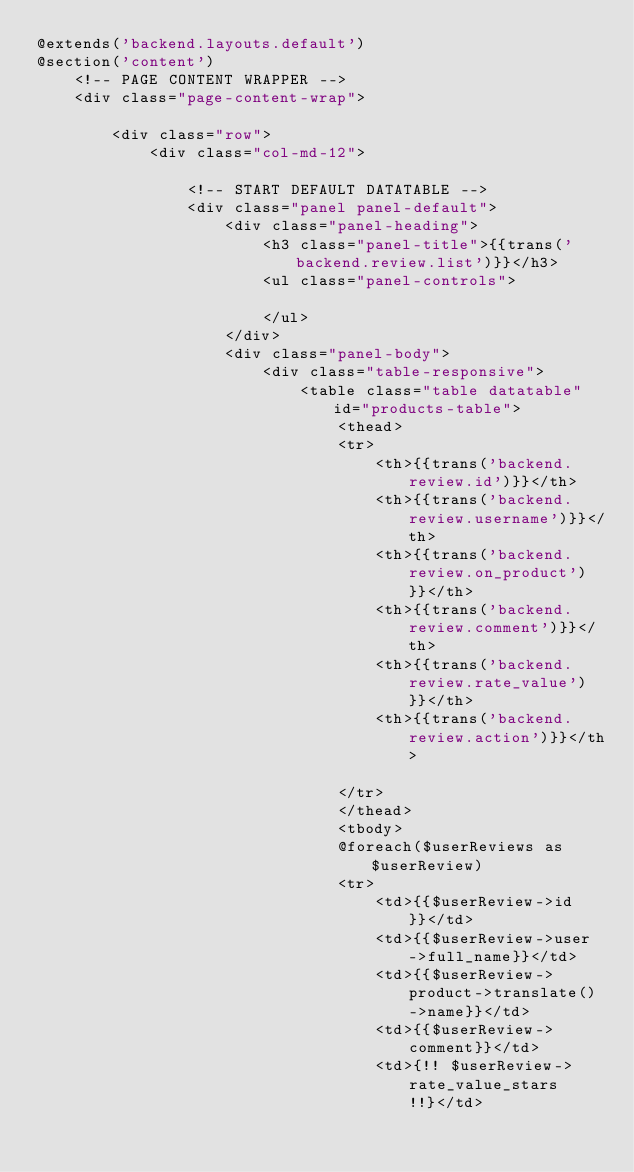Convert code to text. <code><loc_0><loc_0><loc_500><loc_500><_PHP_>@extends('backend.layouts.default')
@section('content')
    <!-- PAGE CONTENT WRAPPER -->
    <div class="page-content-wrap">

        <div class="row">
            <div class="col-md-12">

                <!-- START DEFAULT DATATABLE -->
                <div class="panel panel-default">
                    <div class="panel-heading">
                        <h3 class="panel-title">{{trans('backend.review.list')}}</h3>
                        <ul class="panel-controls">

                        </ul>
                    </div>
                    <div class="panel-body">
                        <div class="table-responsive">
                            <table class="table datatable" id="products-table">
                                <thead>
                                <tr>
                                    <th>{{trans('backend.review.id')}}</th>
                                    <th>{{trans('backend.review.username')}}</th>
                                    <th>{{trans('backend.review.on_product')}}</th>
                                    <th>{{trans('backend.review.comment')}}</th>
                                    <th>{{trans('backend.review.rate_value')}}</th>
                                    <th>{{trans('backend.review.action')}}</th>

                                </tr>
                                </thead>
                                <tbody>
                                @foreach($userReviews as $userReview)
                                <tr>
                                    <td>{{$userReview->id}}</td>
                                    <td>{{$userReview->user->full_name}}</td>
                                    <td>{{$userReview->product->translate()->name}}</td>
                                    <td>{{$userReview->comment}}</td>
                                    <td>{!! $userReview->rate_value_stars !!}</td></code> 